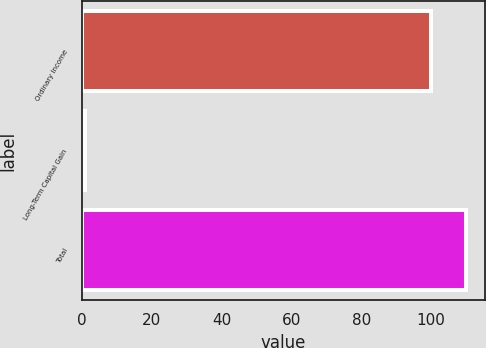Convert chart. <chart><loc_0><loc_0><loc_500><loc_500><bar_chart><fcel>Ordinary Income<fcel>Long-Term Capital Gain<fcel>Total<nl><fcel>100<fcel>0.91<fcel>109.91<nl></chart> 